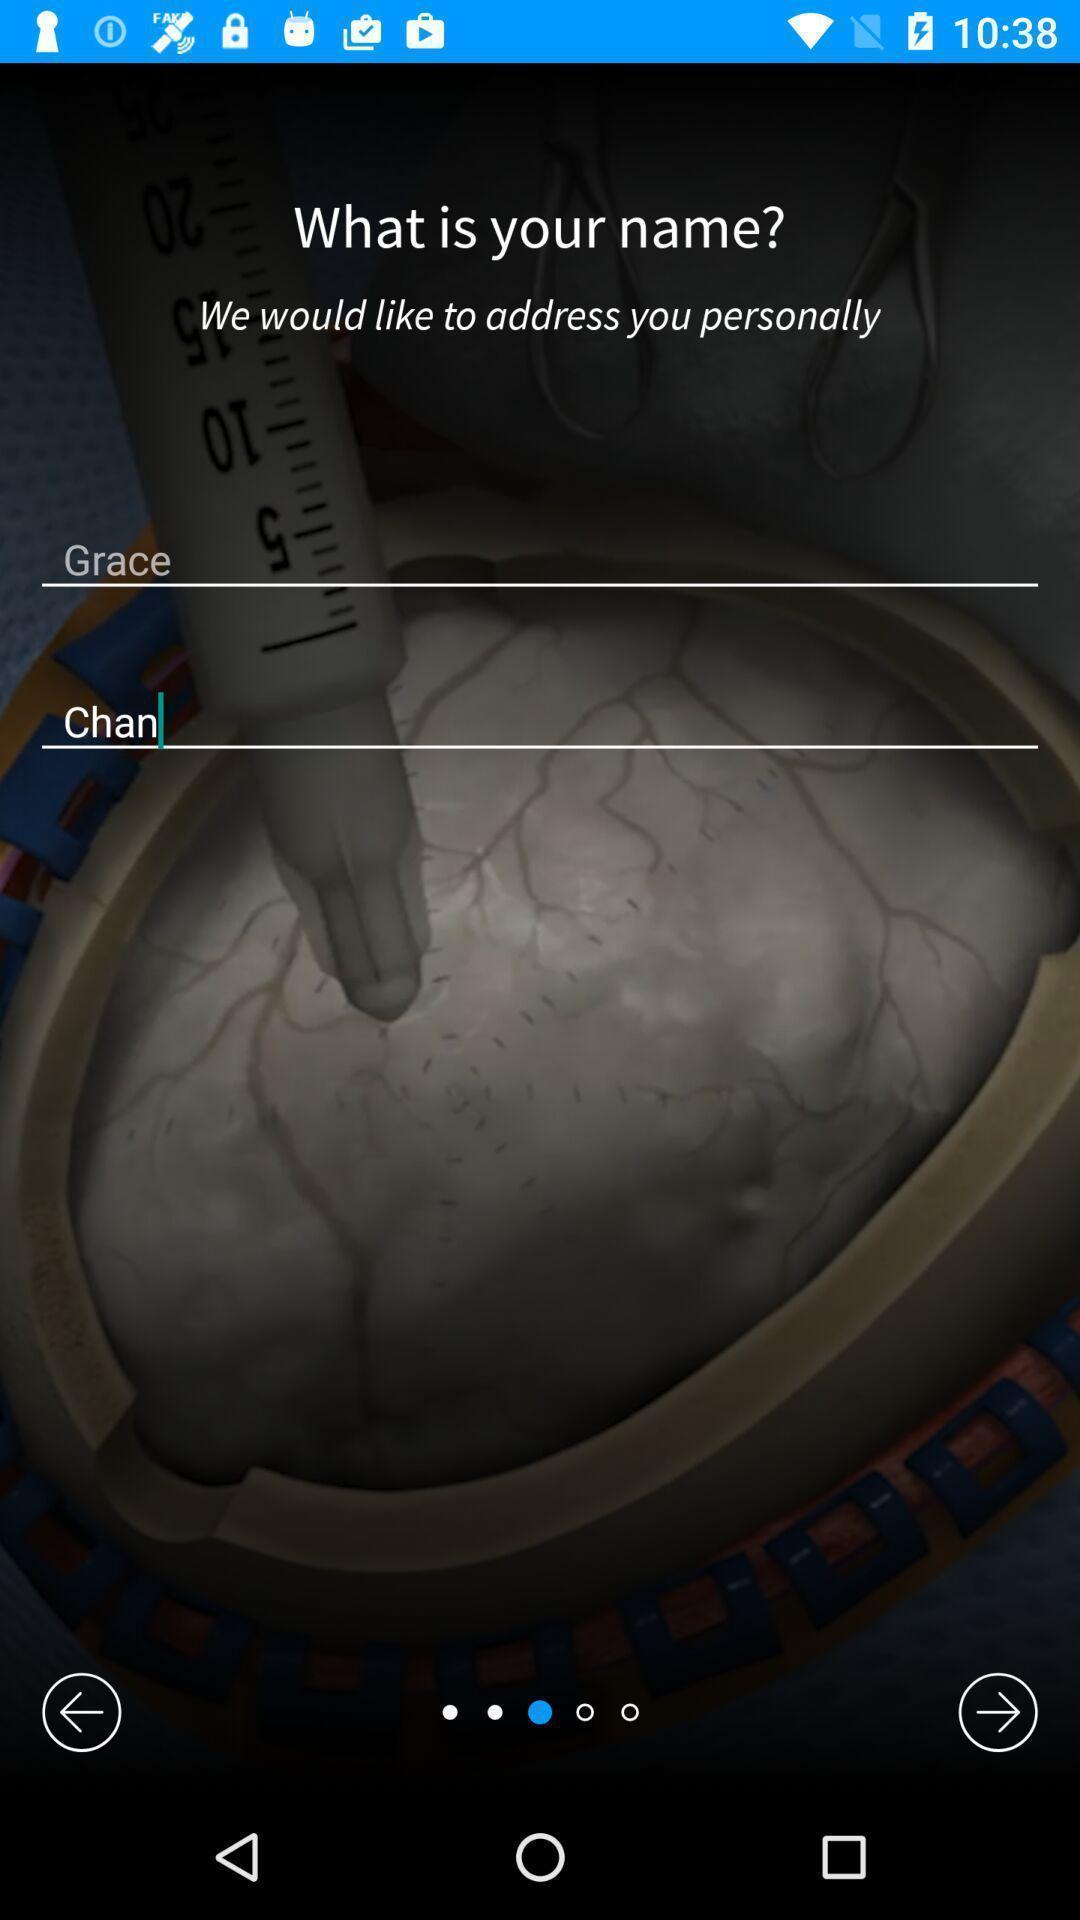Tell me what you see in this picture. Page that displaying a question. 